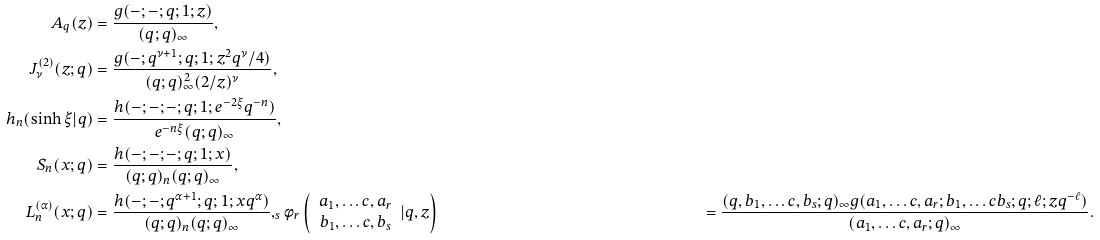Convert formula to latex. <formula><loc_0><loc_0><loc_500><loc_500>A _ { q } ( z ) & = \frac { g ( - ; - ; q ; 1 ; z ) } { ( q ; q ) _ { \infty } } , \\ J _ { \nu } ^ { ( 2 ) } ( z ; q ) & = \frac { g ( - ; q ^ { \nu + 1 } ; q ; 1 ; z ^ { 2 } q ^ { \nu } / 4 ) } { ( q ; q ) _ { \infty } ^ { 2 } ( 2 / z ) ^ { \nu } } , \\ h _ { n } ( \sinh \xi | q ) & = \frac { h ( - ; - ; - ; q ; 1 ; e ^ { - 2 \xi } q ^ { - n } ) } { e ^ { - n \xi } ( q ; q ) _ { \infty } } , \\ S _ { n } ( x ; q ) & = \frac { h ( - ; - ; - ; q ; 1 ; x ) } { ( q ; q ) _ { n } ( q ; q ) _ { \infty } } , \\ L _ { n } ^ { ( \alpha ) } ( x ; q ) & = \frac { h ( - ; - ; q ^ { \alpha + 1 } ; q ; 1 ; x q ^ { \alpha } ) } { ( q ; q ) _ { n } ( q ; q ) _ { \infty } } , _ { s } \phi _ { r } \left ( \begin{array} { c } a _ { 1 } , \dots c , a _ { r } \\ b _ { 1 } , \dots c , b _ { s } \end{array} | q , z \right ) & = \frac { ( q , b _ { 1 } , \dots c , b _ { s } ; q ) _ { \infty } g ( a _ { 1 } , \dots c , a _ { r } ; b _ { 1 } , \dots c b _ { s } ; q ; \ell ; z q ^ { - \ell } ) } { ( a _ { 1 } , \dots c , a _ { r } ; q ) _ { \infty } } .</formula> 